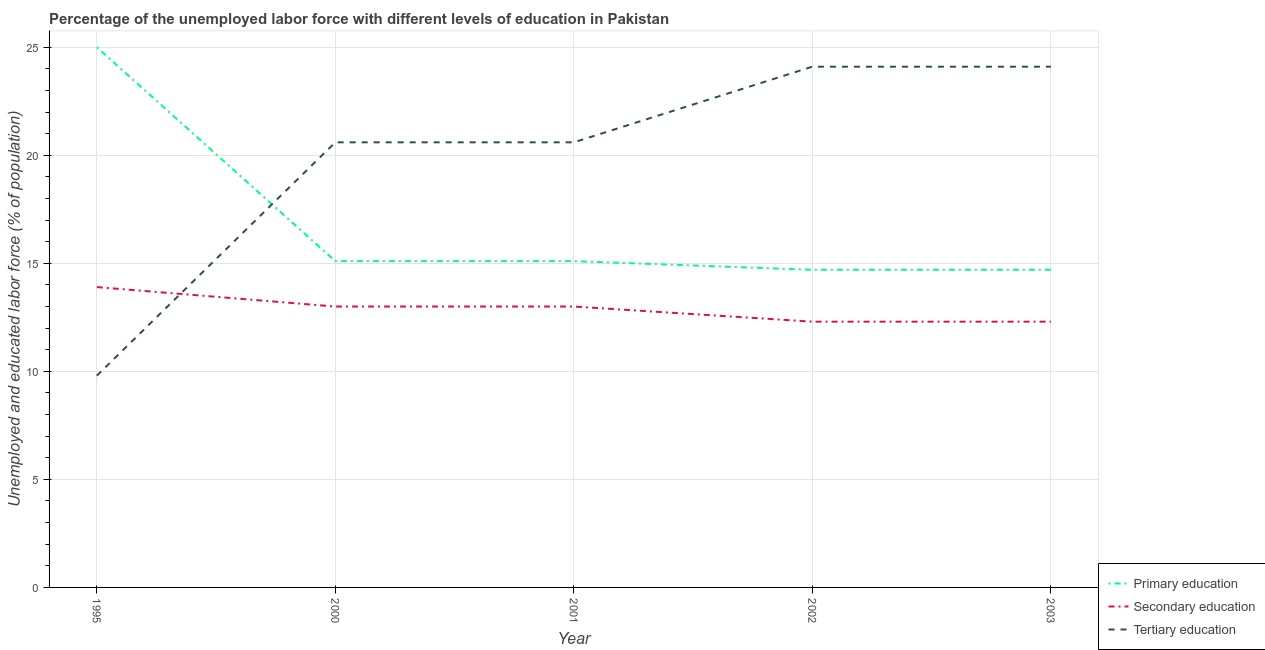Is the number of lines equal to the number of legend labels?
Provide a succinct answer. Yes. What is the percentage of labor force who received secondary education in 2003?
Make the answer very short. 12.3. Across all years, what is the maximum percentage of labor force who received primary education?
Provide a succinct answer. 25. Across all years, what is the minimum percentage of labor force who received tertiary education?
Your answer should be compact. 9.8. What is the total percentage of labor force who received secondary education in the graph?
Ensure brevity in your answer.  64.5. What is the difference between the percentage of labor force who received secondary education in 2002 and the percentage of labor force who received primary education in 2003?
Ensure brevity in your answer.  -2.4. What is the average percentage of labor force who received secondary education per year?
Provide a short and direct response. 12.9. In the year 2003, what is the difference between the percentage of labor force who received primary education and percentage of labor force who received tertiary education?
Offer a terse response. -9.4. Is the percentage of labor force who received primary education in 1995 less than that in 2003?
Make the answer very short. No. Is the difference between the percentage of labor force who received tertiary education in 2001 and 2003 greater than the difference between the percentage of labor force who received secondary education in 2001 and 2003?
Offer a very short reply. No. What is the difference between the highest and the second highest percentage of labor force who received tertiary education?
Your answer should be compact. 0. What is the difference between the highest and the lowest percentage of labor force who received primary education?
Give a very brief answer. 10.3. Is the sum of the percentage of labor force who received tertiary education in 1995 and 2003 greater than the maximum percentage of labor force who received secondary education across all years?
Ensure brevity in your answer.  Yes. Is it the case that in every year, the sum of the percentage of labor force who received primary education and percentage of labor force who received secondary education is greater than the percentage of labor force who received tertiary education?
Offer a terse response. Yes. Is the percentage of labor force who received tertiary education strictly less than the percentage of labor force who received secondary education over the years?
Your answer should be compact. No. How many years are there in the graph?
Offer a very short reply. 5. Are the values on the major ticks of Y-axis written in scientific E-notation?
Your answer should be very brief. No. What is the title of the graph?
Give a very brief answer. Percentage of the unemployed labor force with different levels of education in Pakistan. What is the label or title of the Y-axis?
Provide a succinct answer. Unemployed and educated labor force (% of population). What is the Unemployed and educated labor force (% of population) of Secondary education in 1995?
Ensure brevity in your answer.  13.9. What is the Unemployed and educated labor force (% of population) in Tertiary education in 1995?
Offer a very short reply. 9.8. What is the Unemployed and educated labor force (% of population) in Primary education in 2000?
Your answer should be compact. 15.1. What is the Unemployed and educated labor force (% of population) in Tertiary education in 2000?
Offer a very short reply. 20.6. What is the Unemployed and educated labor force (% of population) of Primary education in 2001?
Your answer should be very brief. 15.1. What is the Unemployed and educated labor force (% of population) in Secondary education in 2001?
Your answer should be very brief. 13. What is the Unemployed and educated labor force (% of population) of Tertiary education in 2001?
Make the answer very short. 20.6. What is the Unemployed and educated labor force (% of population) of Primary education in 2002?
Keep it short and to the point. 14.7. What is the Unemployed and educated labor force (% of population) in Secondary education in 2002?
Keep it short and to the point. 12.3. What is the Unemployed and educated labor force (% of population) of Tertiary education in 2002?
Ensure brevity in your answer.  24.1. What is the Unemployed and educated labor force (% of population) in Primary education in 2003?
Offer a terse response. 14.7. What is the Unemployed and educated labor force (% of population) in Secondary education in 2003?
Keep it short and to the point. 12.3. What is the Unemployed and educated labor force (% of population) of Tertiary education in 2003?
Give a very brief answer. 24.1. Across all years, what is the maximum Unemployed and educated labor force (% of population) of Secondary education?
Keep it short and to the point. 13.9. Across all years, what is the maximum Unemployed and educated labor force (% of population) in Tertiary education?
Your answer should be compact. 24.1. Across all years, what is the minimum Unemployed and educated labor force (% of population) of Primary education?
Offer a very short reply. 14.7. Across all years, what is the minimum Unemployed and educated labor force (% of population) in Secondary education?
Offer a terse response. 12.3. Across all years, what is the minimum Unemployed and educated labor force (% of population) in Tertiary education?
Keep it short and to the point. 9.8. What is the total Unemployed and educated labor force (% of population) in Primary education in the graph?
Your response must be concise. 84.6. What is the total Unemployed and educated labor force (% of population) of Secondary education in the graph?
Offer a terse response. 64.5. What is the total Unemployed and educated labor force (% of population) of Tertiary education in the graph?
Offer a very short reply. 99.2. What is the difference between the Unemployed and educated labor force (% of population) of Primary education in 1995 and that in 2000?
Provide a succinct answer. 9.9. What is the difference between the Unemployed and educated labor force (% of population) of Secondary education in 1995 and that in 2000?
Give a very brief answer. 0.9. What is the difference between the Unemployed and educated labor force (% of population) of Tertiary education in 1995 and that in 2000?
Ensure brevity in your answer.  -10.8. What is the difference between the Unemployed and educated labor force (% of population) in Tertiary education in 1995 and that in 2001?
Keep it short and to the point. -10.8. What is the difference between the Unemployed and educated labor force (% of population) in Primary education in 1995 and that in 2002?
Your answer should be compact. 10.3. What is the difference between the Unemployed and educated labor force (% of population) of Tertiary education in 1995 and that in 2002?
Provide a short and direct response. -14.3. What is the difference between the Unemployed and educated labor force (% of population) in Primary education in 1995 and that in 2003?
Your answer should be compact. 10.3. What is the difference between the Unemployed and educated labor force (% of population) in Tertiary education in 1995 and that in 2003?
Offer a terse response. -14.3. What is the difference between the Unemployed and educated labor force (% of population) of Primary education in 2000 and that in 2001?
Provide a succinct answer. 0. What is the difference between the Unemployed and educated labor force (% of population) in Secondary education in 2000 and that in 2001?
Your answer should be very brief. 0. What is the difference between the Unemployed and educated labor force (% of population) in Tertiary education in 2000 and that in 2002?
Your response must be concise. -3.5. What is the difference between the Unemployed and educated labor force (% of population) of Tertiary education in 2000 and that in 2003?
Provide a short and direct response. -3.5. What is the difference between the Unemployed and educated labor force (% of population) of Primary education in 2001 and that in 2002?
Provide a succinct answer. 0.4. What is the difference between the Unemployed and educated labor force (% of population) of Secondary education in 2001 and that in 2002?
Keep it short and to the point. 0.7. What is the difference between the Unemployed and educated labor force (% of population) of Primary education in 2001 and that in 2003?
Offer a terse response. 0.4. What is the difference between the Unemployed and educated labor force (% of population) of Secondary education in 2001 and that in 2003?
Keep it short and to the point. 0.7. What is the difference between the Unemployed and educated labor force (% of population) in Primary education in 2002 and that in 2003?
Provide a succinct answer. 0. What is the difference between the Unemployed and educated labor force (% of population) of Secondary education in 2002 and that in 2003?
Your answer should be compact. 0. What is the difference between the Unemployed and educated labor force (% of population) of Tertiary education in 2002 and that in 2003?
Provide a short and direct response. 0. What is the difference between the Unemployed and educated labor force (% of population) of Primary education in 1995 and the Unemployed and educated labor force (% of population) of Tertiary education in 2000?
Give a very brief answer. 4.4. What is the difference between the Unemployed and educated labor force (% of population) in Primary education in 1995 and the Unemployed and educated labor force (% of population) in Tertiary education in 2001?
Your answer should be very brief. 4.4. What is the difference between the Unemployed and educated labor force (% of population) in Primary education in 1995 and the Unemployed and educated labor force (% of population) in Secondary education in 2002?
Your answer should be very brief. 12.7. What is the difference between the Unemployed and educated labor force (% of population) of Primary education in 1995 and the Unemployed and educated labor force (% of population) of Tertiary education in 2002?
Offer a terse response. 0.9. What is the difference between the Unemployed and educated labor force (% of population) of Secondary education in 1995 and the Unemployed and educated labor force (% of population) of Tertiary education in 2002?
Offer a very short reply. -10.2. What is the difference between the Unemployed and educated labor force (% of population) of Primary education in 1995 and the Unemployed and educated labor force (% of population) of Secondary education in 2003?
Provide a short and direct response. 12.7. What is the difference between the Unemployed and educated labor force (% of population) in Secondary education in 1995 and the Unemployed and educated labor force (% of population) in Tertiary education in 2003?
Give a very brief answer. -10.2. What is the difference between the Unemployed and educated labor force (% of population) of Primary education in 2000 and the Unemployed and educated labor force (% of population) of Secondary education in 2001?
Offer a terse response. 2.1. What is the difference between the Unemployed and educated labor force (% of population) of Primary education in 2000 and the Unemployed and educated labor force (% of population) of Tertiary education in 2002?
Your response must be concise. -9. What is the difference between the Unemployed and educated labor force (% of population) in Primary education in 2000 and the Unemployed and educated labor force (% of population) in Secondary education in 2003?
Your answer should be compact. 2.8. What is the difference between the Unemployed and educated labor force (% of population) of Primary education in 2000 and the Unemployed and educated labor force (% of population) of Tertiary education in 2003?
Give a very brief answer. -9. What is the difference between the Unemployed and educated labor force (% of population) of Secondary education in 2000 and the Unemployed and educated labor force (% of population) of Tertiary education in 2003?
Your answer should be very brief. -11.1. What is the difference between the Unemployed and educated labor force (% of population) of Secondary education in 2001 and the Unemployed and educated labor force (% of population) of Tertiary education in 2002?
Your answer should be very brief. -11.1. What is the difference between the Unemployed and educated labor force (% of population) of Primary education in 2001 and the Unemployed and educated labor force (% of population) of Tertiary education in 2003?
Give a very brief answer. -9. What is the difference between the Unemployed and educated labor force (% of population) of Primary education in 2002 and the Unemployed and educated labor force (% of population) of Tertiary education in 2003?
Provide a succinct answer. -9.4. What is the difference between the Unemployed and educated labor force (% of population) in Secondary education in 2002 and the Unemployed and educated labor force (% of population) in Tertiary education in 2003?
Your response must be concise. -11.8. What is the average Unemployed and educated labor force (% of population) in Primary education per year?
Your answer should be very brief. 16.92. What is the average Unemployed and educated labor force (% of population) of Secondary education per year?
Offer a terse response. 12.9. What is the average Unemployed and educated labor force (% of population) of Tertiary education per year?
Give a very brief answer. 19.84. In the year 1995, what is the difference between the Unemployed and educated labor force (% of population) in Primary education and Unemployed and educated labor force (% of population) in Secondary education?
Keep it short and to the point. 11.1. In the year 1995, what is the difference between the Unemployed and educated labor force (% of population) of Primary education and Unemployed and educated labor force (% of population) of Tertiary education?
Give a very brief answer. 15.2. In the year 2000, what is the difference between the Unemployed and educated labor force (% of population) of Primary education and Unemployed and educated labor force (% of population) of Tertiary education?
Your response must be concise. -5.5. In the year 2000, what is the difference between the Unemployed and educated labor force (% of population) of Secondary education and Unemployed and educated labor force (% of population) of Tertiary education?
Offer a terse response. -7.6. In the year 2001, what is the difference between the Unemployed and educated labor force (% of population) in Primary education and Unemployed and educated labor force (% of population) in Secondary education?
Keep it short and to the point. 2.1. In the year 2001, what is the difference between the Unemployed and educated labor force (% of population) in Secondary education and Unemployed and educated labor force (% of population) in Tertiary education?
Your answer should be very brief. -7.6. In the year 2002, what is the difference between the Unemployed and educated labor force (% of population) in Primary education and Unemployed and educated labor force (% of population) in Secondary education?
Provide a short and direct response. 2.4. In the year 2003, what is the difference between the Unemployed and educated labor force (% of population) in Secondary education and Unemployed and educated labor force (% of population) in Tertiary education?
Make the answer very short. -11.8. What is the ratio of the Unemployed and educated labor force (% of population) of Primary education in 1995 to that in 2000?
Ensure brevity in your answer.  1.66. What is the ratio of the Unemployed and educated labor force (% of population) of Secondary education in 1995 to that in 2000?
Offer a terse response. 1.07. What is the ratio of the Unemployed and educated labor force (% of population) of Tertiary education in 1995 to that in 2000?
Provide a short and direct response. 0.48. What is the ratio of the Unemployed and educated labor force (% of population) of Primary education in 1995 to that in 2001?
Your answer should be very brief. 1.66. What is the ratio of the Unemployed and educated labor force (% of population) of Secondary education in 1995 to that in 2001?
Your answer should be compact. 1.07. What is the ratio of the Unemployed and educated labor force (% of population) in Tertiary education in 1995 to that in 2001?
Your response must be concise. 0.48. What is the ratio of the Unemployed and educated labor force (% of population) of Primary education in 1995 to that in 2002?
Your answer should be very brief. 1.7. What is the ratio of the Unemployed and educated labor force (% of population) in Secondary education in 1995 to that in 2002?
Make the answer very short. 1.13. What is the ratio of the Unemployed and educated labor force (% of population) in Tertiary education in 1995 to that in 2002?
Make the answer very short. 0.41. What is the ratio of the Unemployed and educated labor force (% of population) of Primary education in 1995 to that in 2003?
Give a very brief answer. 1.7. What is the ratio of the Unemployed and educated labor force (% of population) of Secondary education in 1995 to that in 2003?
Offer a very short reply. 1.13. What is the ratio of the Unemployed and educated labor force (% of population) of Tertiary education in 1995 to that in 2003?
Your answer should be compact. 0.41. What is the ratio of the Unemployed and educated labor force (% of population) of Primary education in 2000 to that in 2002?
Provide a short and direct response. 1.03. What is the ratio of the Unemployed and educated labor force (% of population) of Secondary education in 2000 to that in 2002?
Your answer should be compact. 1.06. What is the ratio of the Unemployed and educated labor force (% of population) of Tertiary education in 2000 to that in 2002?
Give a very brief answer. 0.85. What is the ratio of the Unemployed and educated labor force (% of population) of Primary education in 2000 to that in 2003?
Offer a very short reply. 1.03. What is the ratio of the Unemployed and educated labor force (% of population) in Secondary education in 2000 to that in 2003?
Your response must be concise. 1.06. What is the ratio of the Unemployed and educated labor force (% of population) in Tertiary education in 2000 to that in 2003?
Give a very brief answer. 0.85. What is the ratio of the Unemployed and educated labor force (% of population) of Primary education in 2001 to that in 2002?
Offer a very short reply. 1.03. What is the ratio of the Unemployed and educated labor force (% of population) of Secondary education in 2001 to that in 2002?
Your response must be concise. 1.06. What is the ratio of the Unemployed and educated labor force (% of population) in Tertiary education in 2001 to that in 2002?
Keep it short and to the point. 0.85. What is the ratio of the Unemployed and educated labor force (% of population) in Primary education in 2001 to that in 2003?
Give a very brief answer. 1.03. What is the ratio of the Unemployed and educated labor force (% of population) in Secondary education in 2001 to that in 2003?
Your answer should be very brief. 1.06. What is the ratio of the Unemployed and educated labor force (% of population) of Tertiary education in 2001 to that in 2003?
Keep it short and to the point. 0.85. What is the ratio of the Unemployed and educated labor force (% of population) in Secondary education in 2002 to that in 2003?
Offer a terse response. 1. What is the ratio of the Unemployed and educated labor force (% of population) in Tertiary education in 2002 to that in 2003?
Offer a terse response. 1. What is the difference between the highest and the second highest Unemployed and educated labor force (% of population) of Primary education?
Your answer should be compact. 9.9. What is the difference between the highest and the second highest Unemployed and educated labor force (% of population) of Tertiary education?
Provide a succinct answer. 0. What is the difference between the highest and the lowest Unemployed and educated labor force (% of population) of Secondary education?
Make the answer very short. 1.6. 